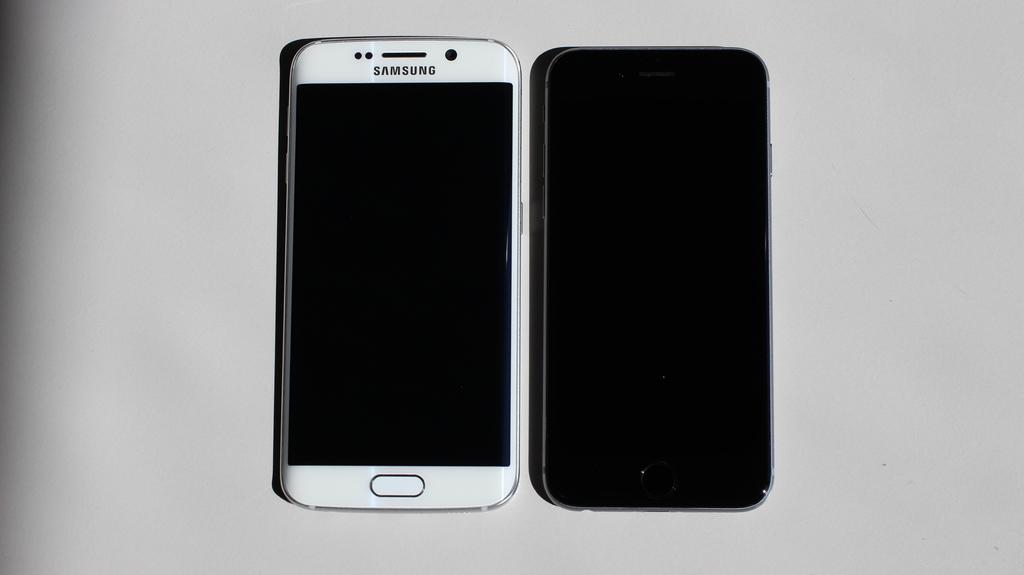<image>
Offer a succinct explanation of the picture presented. A phone that says Samsung likes to the left of a phone that says nothing. 